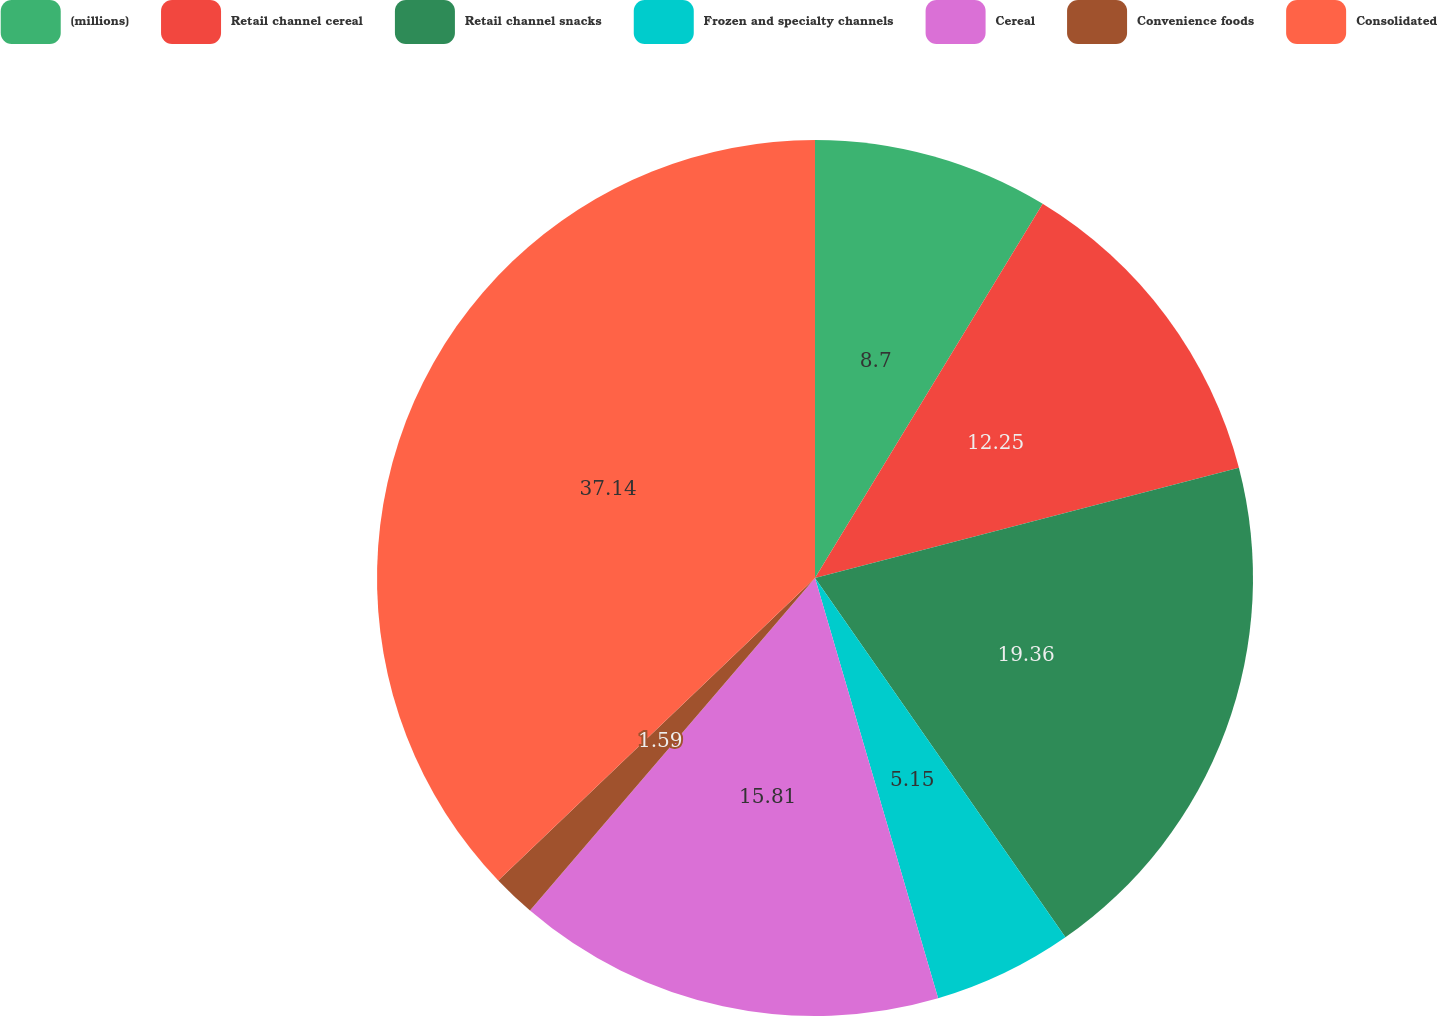Convert chart to OTSL. <chart><loc_0><loc_0><loc_500><loc_500><pie_chart><fcel>(millions)<fcel>Retail channel cereal<fcel>Retail channel snacks<fcel>Frozen and specialty channels<fcel>Cereal<fcel>Convenience foods<fcel>Consolidated<nl><fcel>8.7%<fcel>12.25%<fcel>19.36%<fcel>5.15%<fcel>15.81%<fcel>1.59%<fcel>37.13%<nl></chart> 